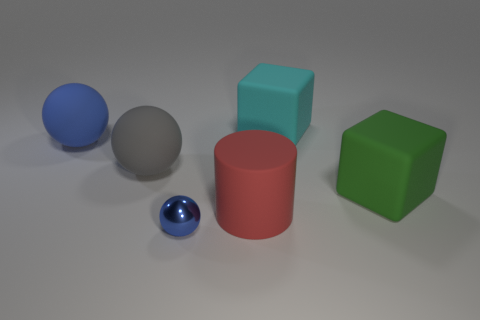How many other cyan objects are the same shape as the large cyan matte thing?
Your answer should be compact. 0. The object behind the blue thing that is behind the big red matte object is what color?
Offer a terse response. Cyan. Are there an equal number of blue things that are to the left of the small metallic object and blocks?
Give a very brief answer. No. Is there a red thing of the same size as the blue matte thing?
Keep it short and to the point. Yes. There is a blue rubber sphere; does it have the same size as the cube on the left side of the big green rubber object?
Your answer should be very brief. Yes. Are there the same number of cyan matte cubes in front of the red thing and large cyan matte blocks left of the big gray rubber thing?
Your answer should be very brief. Yes. What is the shape of the matte object that is the same color as the small metal sphere?
Keep it short and to the point. Sphere. What material is the sphere that is in front of the big green cube?
Your answer should be compact. Metal. Do the red cylinder and the metal ball have the same size?
Offer a very short reply. No. Are there more big red objects behind the red rubber cylinder than purple matte blocks?
Offer a terse response. No. 